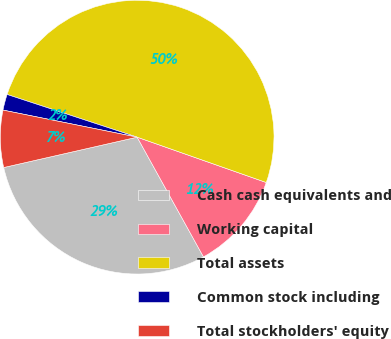Convert chart. <chart><loc_0><loc_0><loc_500><loc_500><pie_chart><fcel>Cash cash equivalents and<fcel>Working capital<fcel>Total assets<fcel>Common stock including<fcel>Total stockholders' equity<nl><fcel>29.49%<fcel>11.57%<fcel>50.33%<fcel>1.88%<fcel>6.73%<nl></chart> 